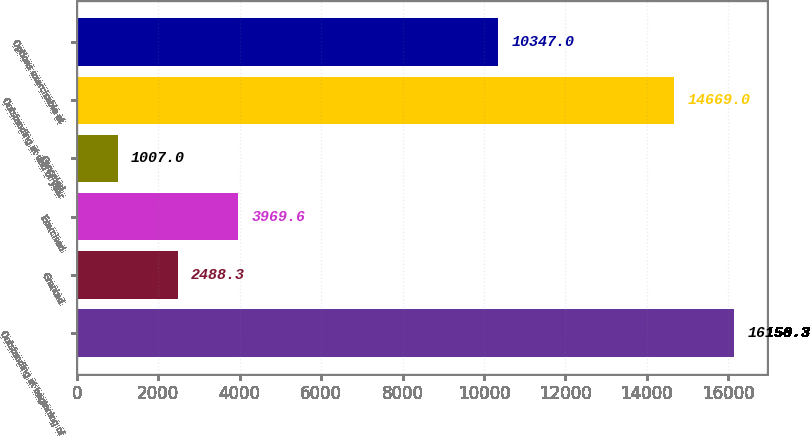Convert chart to OTSL. <chart><loc_0><loc_0><loc_500><loc_500><bar_chart><fcel>Outstanding at beginning of<fcel>Granted<fcel>Exercised<fcel>Canceled<fcel>Outstanding at end of year<fcel>Options exercisable at<nl><fcel>16150.3<fcel>2488.3<fcel>3969.6<fcel>1007<fcel>14669<fcel>10347<nl></chart> 